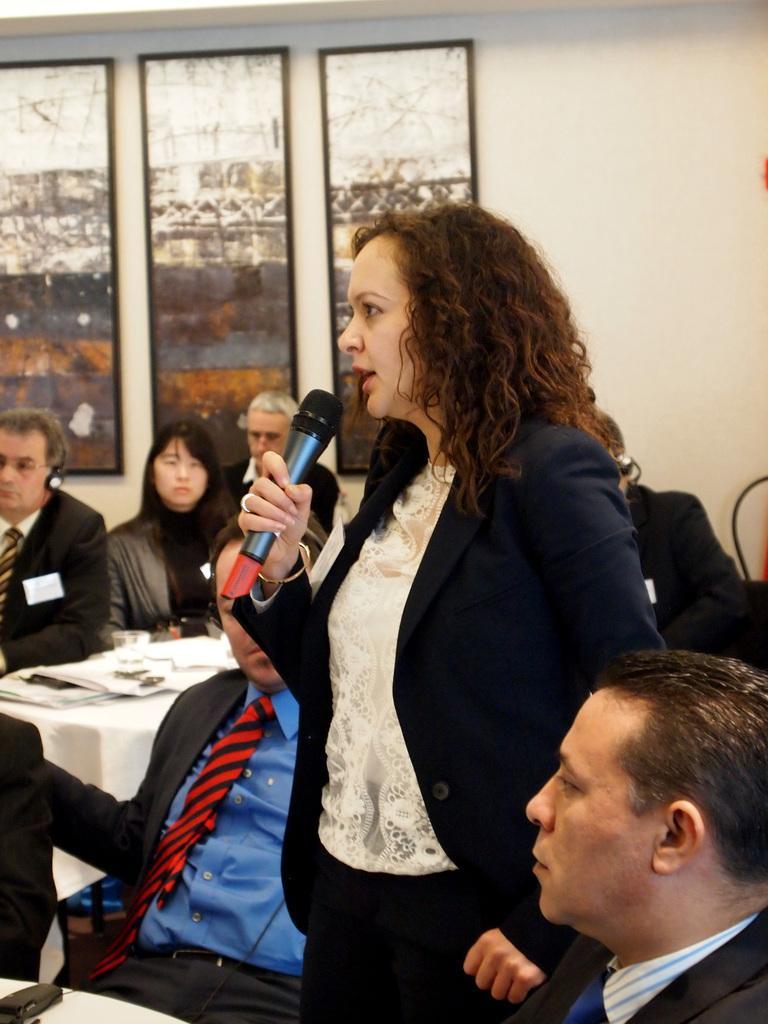Describe this image in one or two sentences. This is a picture taken in a room, there are a group of people sitting on a chair and a woman in black blazer holding a microphone. In front of the people there is a table on the table there are books and glasses. Background of this people there is a wall which is in white color on the wall there are the photo frames. 